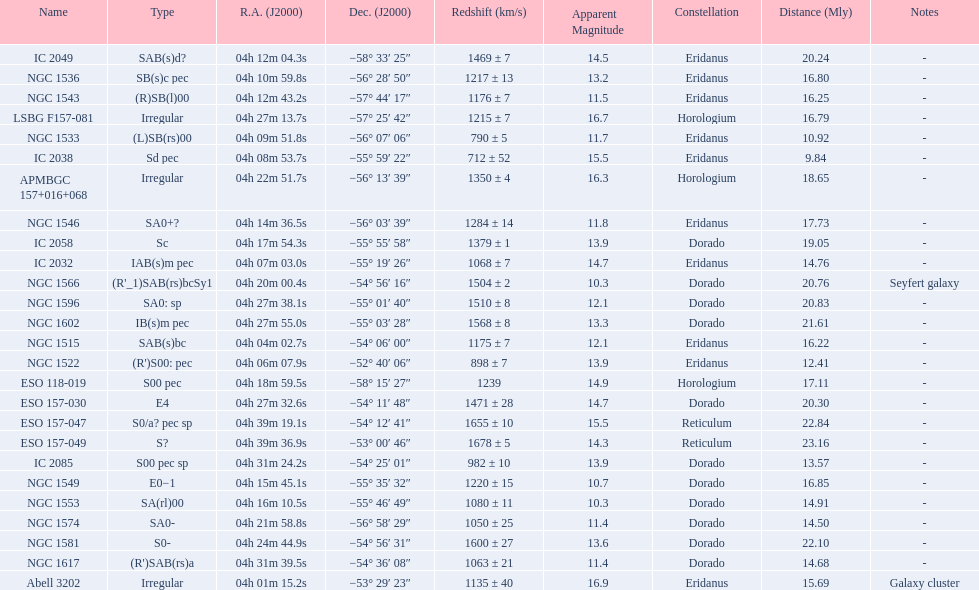Name the member with the highest apparent magnitude. Abell 3202. 